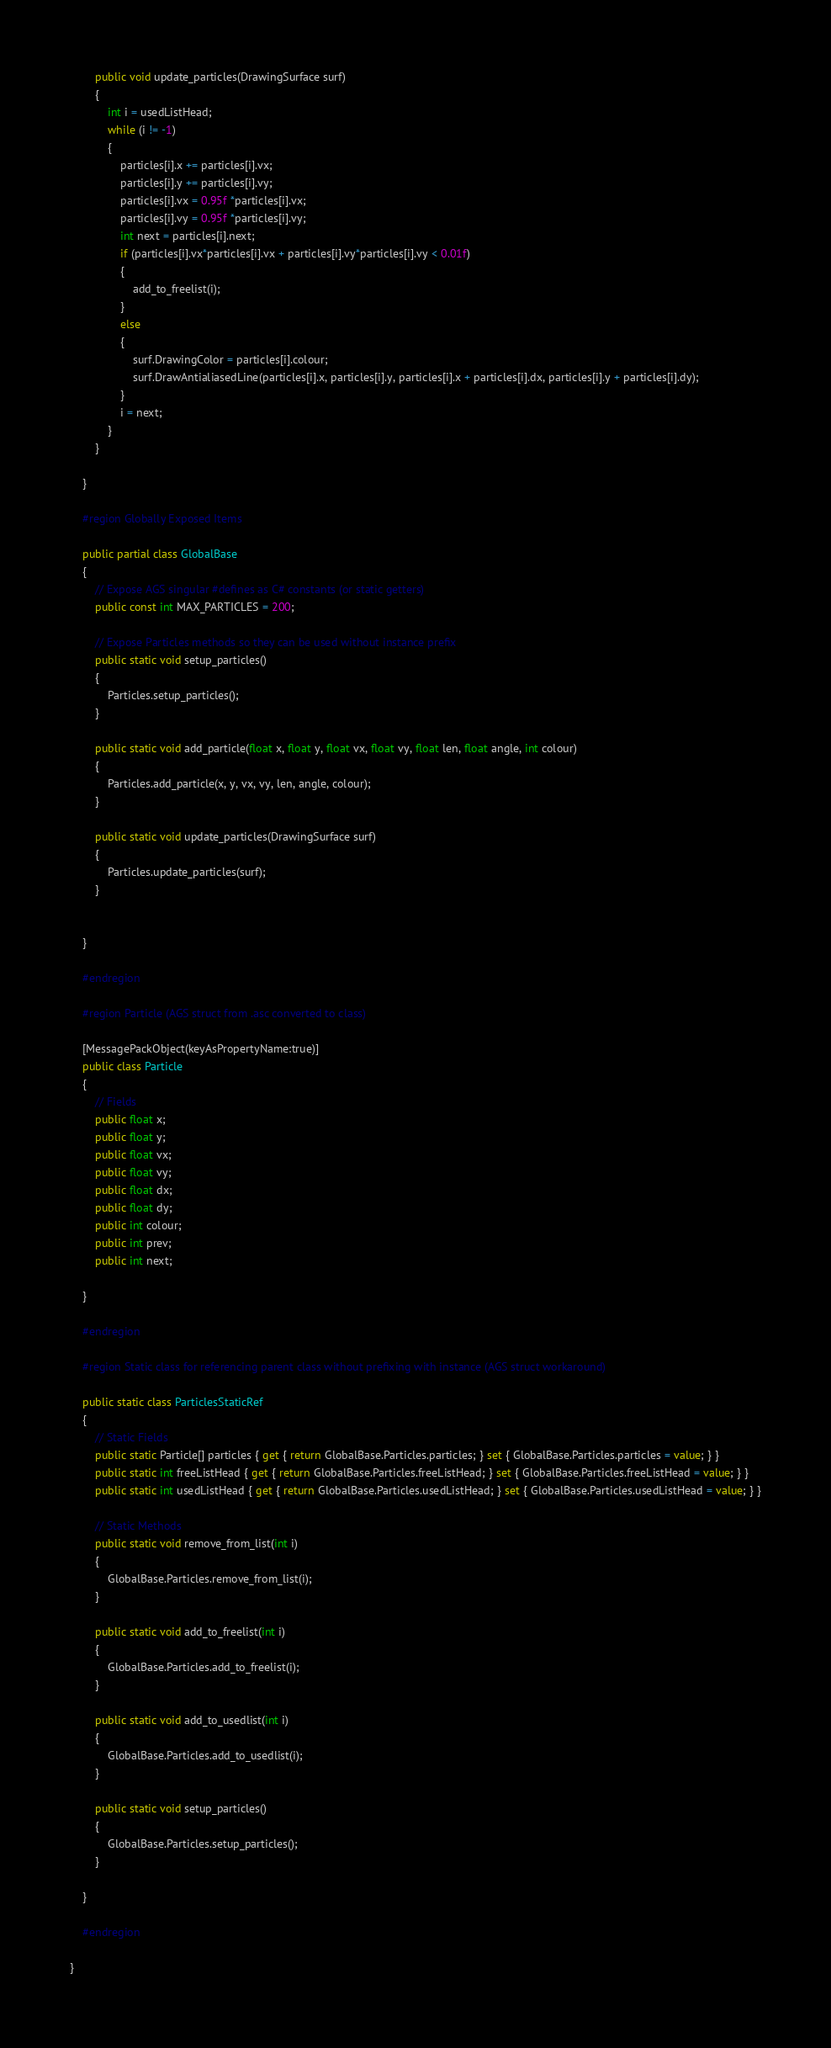Convert code to text. <code><loc_0><loc_0><loc_500><loc_500><_C#_>
        public void update_particles(DrawingSurface surf)
        {
            int i = usedListHead;
            while (i != -1)
            {
                particles[i].x += particles[i].vx;
                particles[i].y += particles[i].vy;
                particles[i].vx = 0.95f *particles[i].vx;
                particles[i].vy = 0.95f *particles[i].vy;
                int next = particles[i].next;
                if (particles[i].vx*particles[i].vx + particles[i].vy*particles[i].vy < 0.01f)
                {
                    add_to_freelist(i);
                }
                else 
                {
                    surf.DrawingColor = particles[i].colour;
                    surf.DrawAntialiasedLine(particles[i].x, particles[i].y, particles[i].x + particles[i].dx, particles[i].y + particles[i].dy);
                }
                i = next;
            }
        }

    }

    #region Globally Exposed Items

    public partial class GlobalBase
    {
        // Expose AGS singular #defines as C# constants (or static getters)
        public const int MAX_PARTICLES = 200;

        // Expose Particles methods so they can be used without instance prefix
        public static void setup_particles()
        {
            Particles.setup_particles();
        }

        public static void add_particle(float x, float y, float vx, float vy, float len, float angle, int colour)
        {
            Particles.add_particle(x, y, vx, vy, len, angle, colour);
        }

        public static void update_particles(DrawingSurface surf)
        {
            Particles.update_particles(surf);
        }


    }

    #endregion

    #region Particle (AGS struct from .asc converted to class)

    [MessagePackObject(keyAsPropertyName:true)]
    public class Particle
    {
        // Fields
        public float x;
        public float y;
        public float vx;
        public float vy;
        public float dx;
        public float dy;
        public int colour;
        public int prev;
        public int next;

    }

    #endregion

    #region Static class for referencing parent class without prefixing with instance (AGS struct workaround)

    public static class ParticlesStaticRef
    {
        // Static Fields
        public static Particle[] particles { get { return GlobalBase.Particles.particles; } set { GlobalBase.Particles.particles = value; } }
        public static int freeListHead { get { return GlobalBase.Particles.freeListHead; } set { GlobalBase.Particles.freeListHead = value; } }
        public static int usedListHead { get { return GlobalBase.Particles.usedListHead; } set { GlobalBase.Particles.usedListHead = value; } }

        // Static Methods
        public static void remove_from_list(int i)
        {
            GlobalBase.Particles.remove_from_list(i);
        }

        public static void add_to_freelist(int i)
        {
            GlobalBase.Particles.add_to_freelist(i);
        }

        public static void add_to_usedlist(int i)
        {
            GlobalBase.Particles.add_to_usedlist(i);
        }

        public static void setup_particles()
        {
            GlobalBase.Particles.setup_particles();
        }

    }

    #endregion
    
}
</code> 